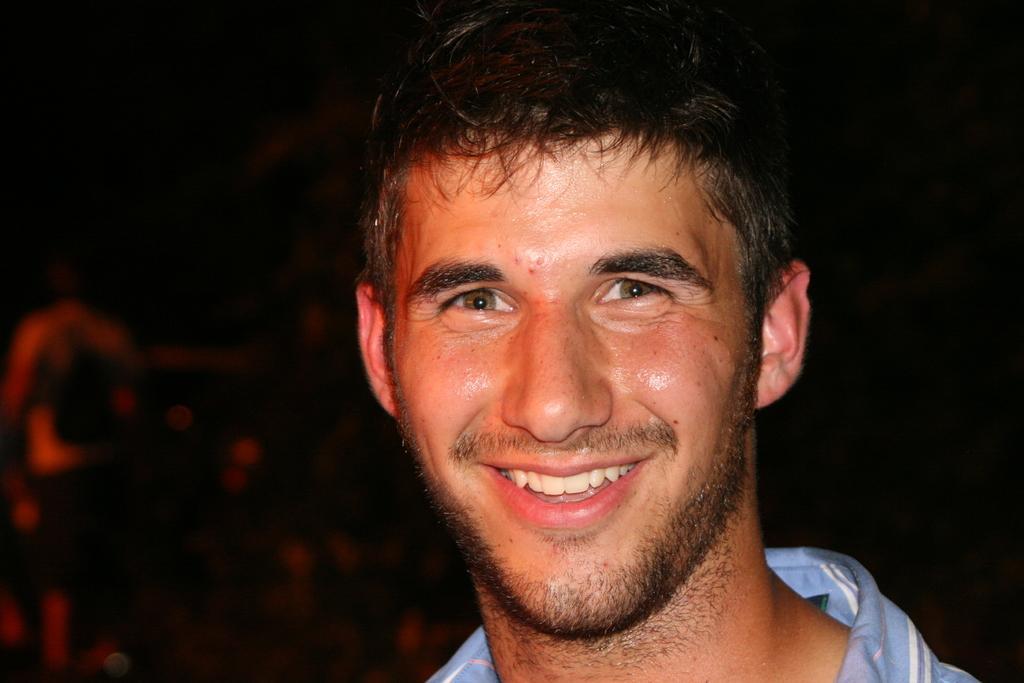Describe this image in one or two sentences. In the foreground of this image, there is man wearing blue shirt and having smile on his face and the background is dark. 